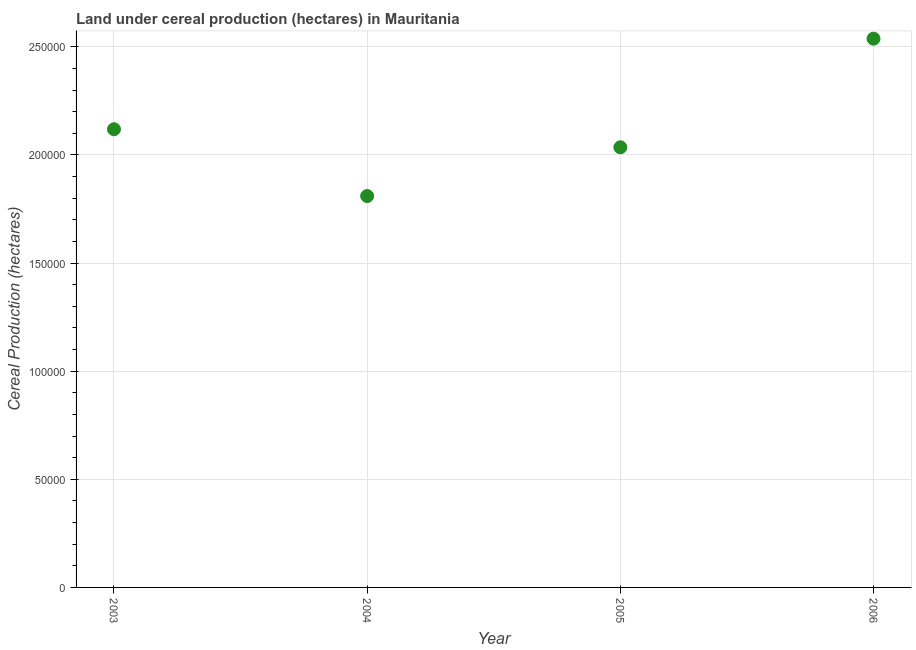What is the land under cereal production in 2006?
Your response must be concise. 2.54e+05. Across all years, what is the maximum land under cereal production?
Ensure brevity in your answer.  2.54e+05. Across all years, what is the minimum land under cereal production?
Make the answer very short. 1.81e+05. In which year was the land under cereal production maximum?
Your answer should be very brief. 2006. In which year was the land under cereal production minimum?
Make the answer very short. 2004. What is the sum of the land under cereal production?
Your answer should be very brief. 8.50e+05. What is the difference between the land under cereal production in 2003 and 2005?
Ensure brevity in your answer.  8361. What is the average land under cereal production per year?
Provide a succinct answer. 2.13e+05. What is the median land under cereal production?
Provide a succinct answer. 2.08e+05. What is the ratio of the land under cereal production in 2003 to that in 2005?
Provide a succinct answer. 1.04. Is the land under cereal production in 2003 less than that in 2006?
Give a very brief answer. Yes. Is the difference between the land under cereal production in 2003 and 2004 greater than the difference between any two years?
Provide a short and direct response. No. What is the difference between the highest and the second highest land under cereal production?
Provide a succinct answer. 4.19e+04. Is the sum of the land under cereal production in 2004 and 2006 greater than the maximum land under cereal production across all years?
Keep it short and to the point. Yes. What is the difference between the highest and the lowest land under cereal production?
Your answer should be very brief. 7.28e+04. In how many years, is the land under cereal production greater than the average land under cereal production taken over all years?
Make the answer very short. 1. How many dotlines are there?
Your response must be concise. 1. How many years are there in the graph?
Ensure brevity in your answer.  4. Are the values on the major ticks of Y-axis written in scientific E-notation?
Your answer should be compact. No. Does the graph contain any zero values?
Ensure brevity in your answer.  No. Does the graph contain grids?
Offer a very short reply. Yes. What is the title of the graph?
Provide a short and direct response. Land under cereal production (hectares) in Mauritania. What is the label or title of the X-axis?
Ensure brevity in your answer.  Year. What is the label or title of the Y-axis?
Provide a succinct answer. Cereal Production (hectares). What is the Cereal Production (hectares) in 2003?
Your answer should be compact. 2.12e+05. What is the Cereal Production (hectares) in 2004?
Your answer should be compact. 1.81e+05. What is the Cereal Production (hectares) in 2005?
Your response must be concise. 2.04e+05. What is the Cereal Production (hectares) in 2006?
Offer a terse response. 2.54e+05. What is the difference between the Cereal Production (hectares) in 2003 and 2004?
Give a very brief answer. 3.09e+04. What is the difference between the Cereal Production (hectares) in 2003 and 2005?
Provide a short and direct response. 8361. What is the difference between the Cereal Production (hectares) in 2003 and 2006?
Your answer should be compact. -4.19e+04. What is the difference between the Cereal Production (hectares) in 2004 and 2005?
Give a very brief answer. -2.25e+04. What is the difference between the Cereal Production (hectares) in 2004 and 2006?
Provide a short and direct response. -7.28e+04. What is the difference between the Cereal Production (hectares) in 2005 and 2006?
Ensure brevity in your answer.  -5.02e+04. What is the ratio of the Cereal Production (hectares) in 2003 to that in 2004?
Keep it short and to the point. 1.17. What is the ratio of the Cereal Production (hectares) in 2003 to that in 2005?
Your answer should be very brief. 1.04. What is the ratio of the Cereal Production (hectares) in 2003 to that in 2006?
Offer a terse response. 0.83. What is the ratio of the Cereal Production (hectares) in 2004 to that in 2005?
Give a very brief answer. 0.89. What is the ratio of the Cereal Production (hectares) in 2004 to that in 2006?
Give a very brief answer. 0.71. What is the ratio of the Cereal Production (hectares) in 2005 to that in 2006?
Your answer should be very brief. 0.8. 